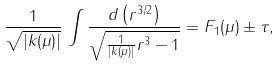Convert formula to latex. <formula><loc_0><loc_0><loc_500><loc_500>\frac { 1 } { \sqrt { | k ( \mu ) | } } \, \int \frac { d \left ( r ^ { 3 / 2 } \right ) } { \sqrt { \frac { 1 } { | k ( \mu ) | } r ^ { 3 } - 1 } } = { F } _ { 1 } ( \mu ) \pm \tau ,</formula> 